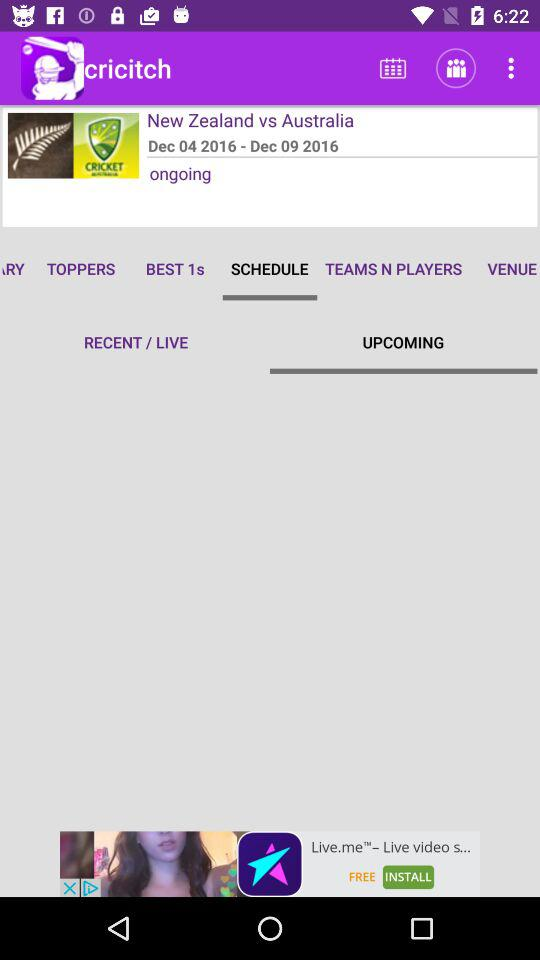What is the status of the match? The status of the match is ongoing. 